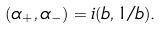<formula> <loc_0><loc_0><loc_500><loc_500>( \alpha _ { + } , \alpha _ { - } ) = i ( b , 1 / b ) .</formula> 